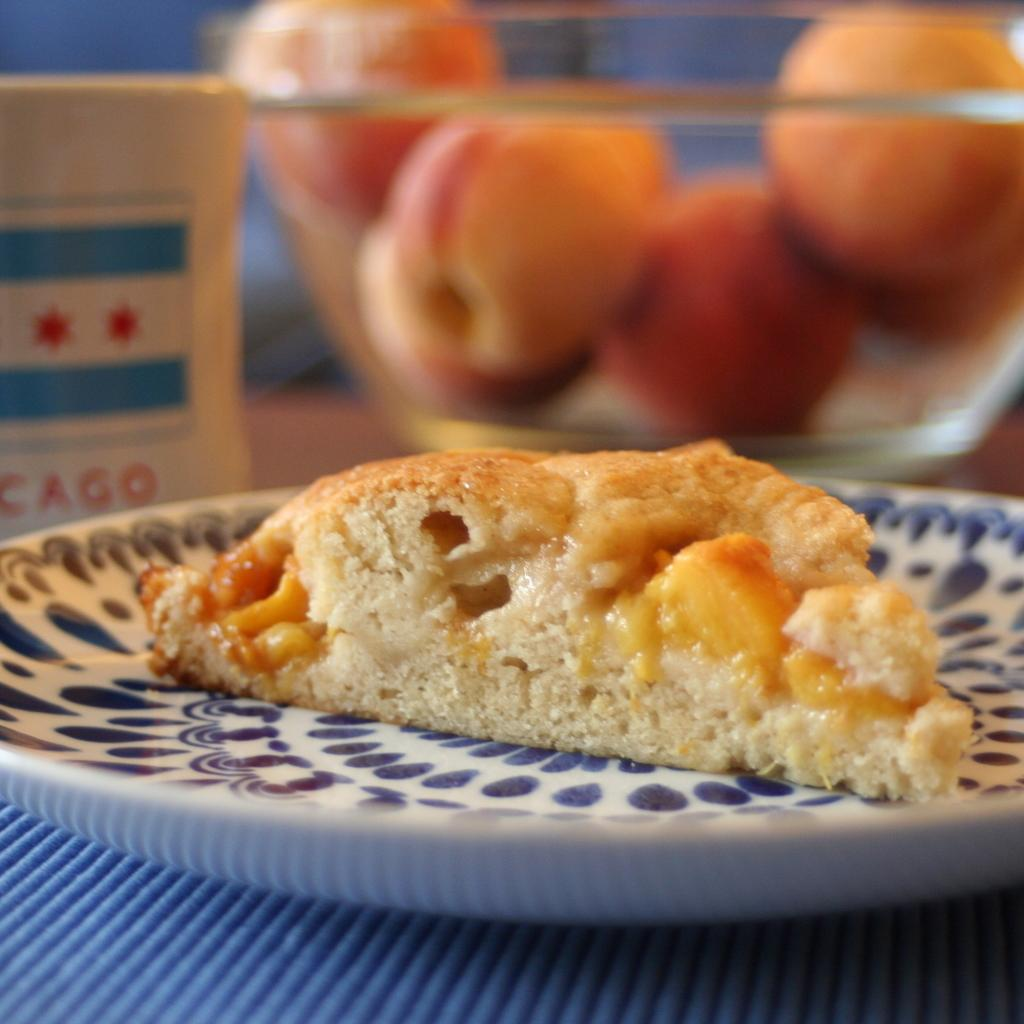What is on the plate in the image? There is food in a plate in the image. What is in the bowl in the image? There are fruits in a bowl in the image. What object is on the table in the image? There is a box on the table in the image. What type of approval is being given by the car in the image? There are no cars present in the image, so approval cannot be given by a car. 